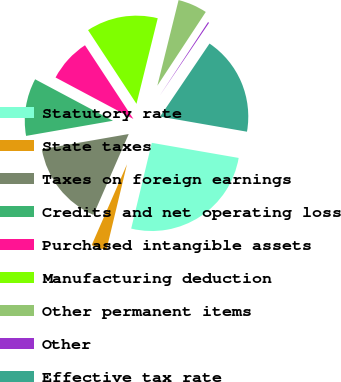Convert chart to OTSL. <chart><loc_0><loc_0><loc_500><loc_500><pie_chart><fcel>Statutory rate<fcel>State taxes<fcel>Taxes on foreign earnings<fcel>Credits and net operating loss<fcel>Purchased intangible assets<fcel>Manufacturing deduction<fcel>Other permanent items<fcel>Other<fcel>Effective tax rate<nl><fcel>26.01%<fcel>2.8%<fcel>15.7%<fcel>10.54%<fcel>7.96%<fcel>13.12%<fcel>5.38%<fcel>0.22%<fcel>18.27%<nl></chart> 